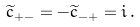<formula> <loc_0><loc_0><loc_500><loc_500>\widetilde { c } _ { + - } = - \widetilde { c } _ { - + } = i \, .</formula> 